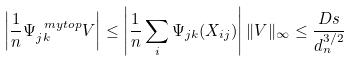Convert formula to latex. <formula><loc_0><loc_0><loc_500><loc_500>\left | \frac { 1 } { n } \Psi _ { j k } ^ { \ m y t o p } V \right | \leq \left | \frac { 1 } { n } \sum _ { i } \Psi _ { j k } ( X _ { i j } ) \right | \| V \| _ { \infty } \leq \frac { D s } { d _ { n } ^ { 3 / 2 } }</formula> 